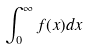<formula> <loc_0><loc_0><loc_500><loc_500>\int _ { 0 } ^ { \infty } f ( x ) d x</formula> 